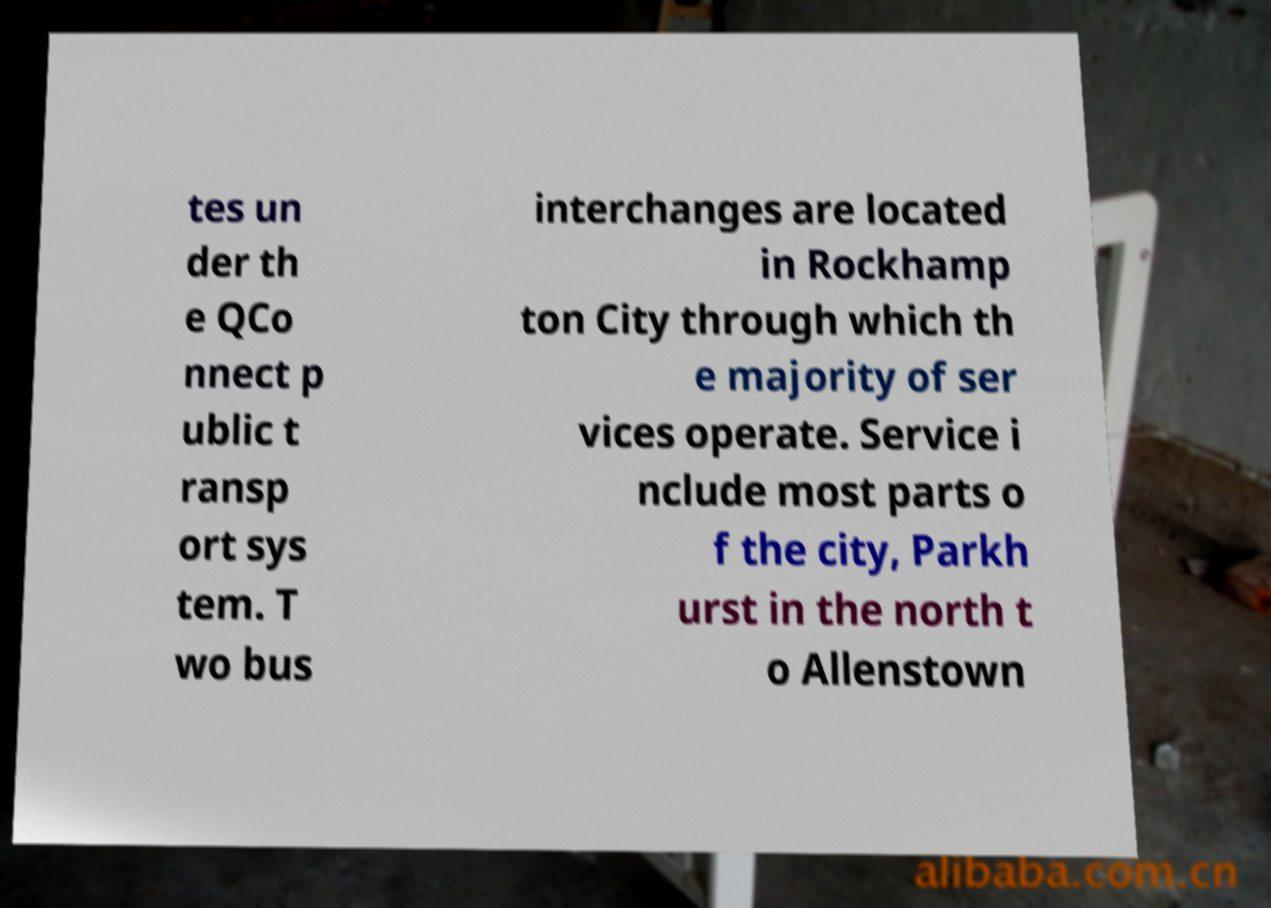For documentation purposes, I need the text within this image transcribed. Could you provide that? tes un der th e QCo nnect p ublic t ransp ort sys tem. T wo bus interchanges are located in Rockhamp ton City through which th e majority of ser vices operate. Service i nclude most parts o f the city, Parkh urst in the north t o Allenstown 